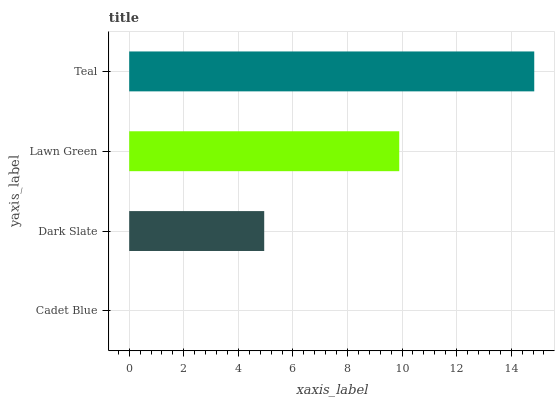Is Cadet Blue the minimum?
Answer yes or no. Yes. Is Teal the maximum?
Answer yes or no. Yes. Is Dark Slate the minimum?
Answer yes or no. No. Is Dark Slate the maximum?
Answer yes or no. No. Is Dark Slate greater than Cadet Blue?
Answer yes or no. Yes. Is Cadet Blue less than Dark Slate?
Answer yes or no. Yes. Is Cadet Blue greater than Dark Slate?
Answer yes or no. No. Is Dark Slate less than Cadet Blue?
Answer yes or no. No. Is Lawn Green the high median?
Answer yes or no. Yes. Is Dark Slate the low median?
Answer yes or no. Yes. Is Cadet Blue the high median?
Answer yes or no. No. Is Teal the low median?
Answer yes or no. No. 